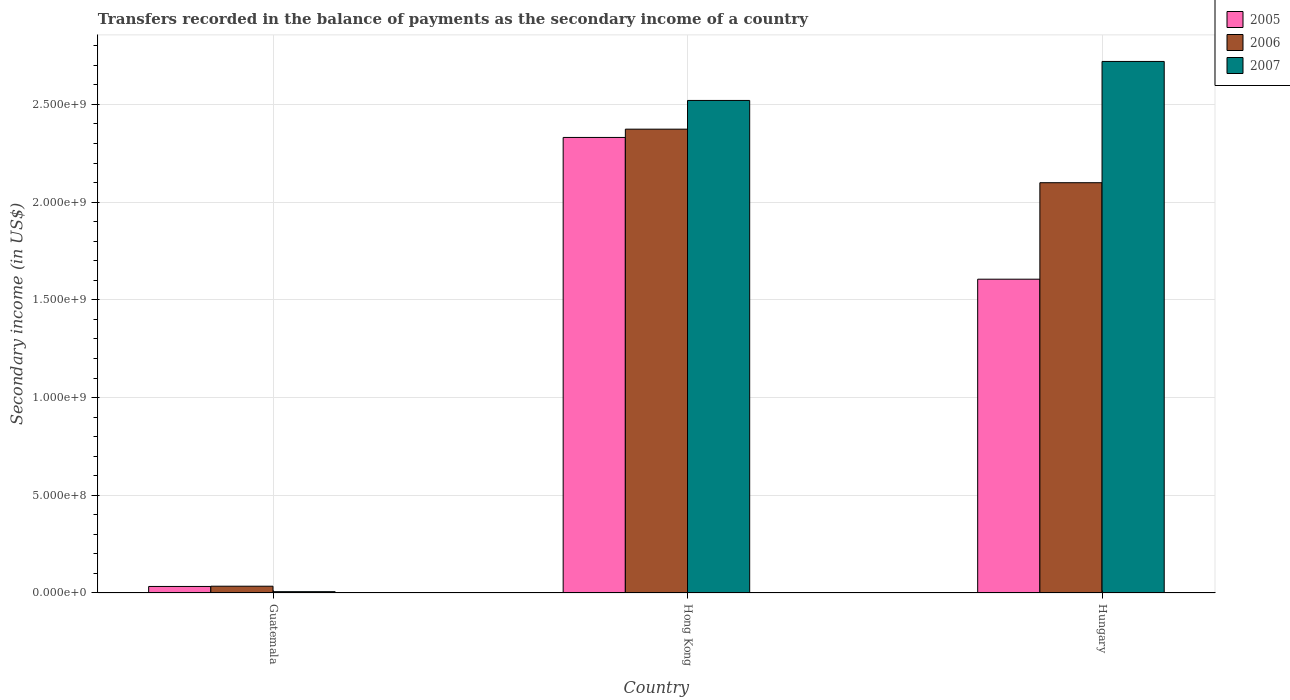How many different coloured bars are there?
Give a very brief answer. 3. How many groups of bars are there?
Make the answer very short. 3. Are the number of bars on each tick of the X-axis equal?
Keep it short and to the point. Yes. What is the label of the 3rd group of bars from the left?
Offer a terse response. Hungary. What is the secondary income of in 2007 in Guatemala?
Give a very brief answer. 6.70e+06. Across all countries, what is the maximum secondary income of in 2007?
Keep it short and to the point. 2.72e+09. Across all countries, what is the minimum secondary income of in 2007?
Make the answer very short. 6.70e+06. In which country was the secondary income of in 2006 maximum?
Ensure brevity in your answer.  Hong Kong. In which country was the secondary income of in 2007 minimum?
Offer a very short reply. Guatemala. What is the total secondary income of in 2006 in the graph?
Offer a terse response. 4.51e+09. What is the difference between the secondary income of in 2007 in Guatemala and that in Hungary?
Provide a short and direct response. -2.71e+09. What is the difference between the secondary income of in 2005 in Hungary and the secondary income of in 2006 in Hong Kong?
Offer a terse response. -7.68e+08. What is the average secondary income of in 2007 per country?
Offer a terse response. 1.75e+09. What is the difference between the secondary income of of/in 2007 and secondary income of of/in 2005 in Hungary?
Your answer should be compact. 1.11e+09. What is the ratio of the secondary income of in 2007 in Guatemala to that in Hungary?
Keep it short and to the point. 0. Is the secondary income of in 2007 in Guatemala less than that in Hungary?
Offer a very short reply. Yes. What is the difference between the highest and the second highest secondary income of in 2005?
Keep it short and to the point. -1.57e+09. What is the difference between the highest and the lowest secondary income of in 2005?
Your answer should be very brief. 2.30e+09. What does the 2nd bar from the right in Hong Kong represents?
Your answer should be compact. 2006. How many bars are there?
Offer a terse response. 9. Are all the bars in the graph horizontal?
Offer a terse response. No. How many countries are there in the graph?
Offer a terse response. 3. What is the difference between two consecutive major ticks on the Y-axis?
Ensure brevity in your answer.  5.00e+08. Are the values on the major ticks of Y-axis written in scientific E-notation?
Offer a terse response. Yes. Does the graph contain any zero values?
Your answer should be very brief. No. What is the title of the graph?
Offer a terse response. Transfers recorded in the balance of payments as the secondary income of a country. What is the label or title of the X-axis?
Ensure brevity in your answer.  Country. What is the label or title of the Y-axis?
Make the answer very short. Secondary income (in US$). What is the Secondary income (in US$) of 2005 in Guatemala?
Offer a terse response. 3.34e+07. What is the Secondary income (in US$) of 2006 in Guatemala?
Give a very brief answer. 3.47e+07. What is the Secondary income (in US$) of 2007 in Guatemala?
Ensure brevity in your answer.  6.70e+06. What is the Secondary income (in US$) of 2005 in Hong Kong?
Your response must be concise. 2.33e+09. What is the Secondary income (in US$) of 2006 in Hong Kong?
Your response must be concise. 2.37e+09. What is the Secondary income (in US$) of 2007 in Hong Kong?
Your response must be concise. 2.52e+09. What is the Secondary income (in US$) of 2005 in Hungary?
Ensure brevity in your answer.  1.61e+09. What is the Secondary income (in US$) in 2006 in Hungary?
Provide a succinct answer. 2.10e+09. What is the Secondary income (in US$) in 2007 in Hungary?
Give a very brief answer. 2.72e+09. Across all countries, what is the maximum Secondary income (in US$) in 2005?
Offer a terse response. 2.33e+09. Across all countries, what is the maximum Secondary income (in US$) in 2006?
Give a very brief answer. 2.37e+09. Across all countries, what is the maximum Secondary income (in US$) in 2007?
Your response must be concise. 2.72e+09. Across all countries, what is the minimum Secondary income (in US$) in 2005?
Provide a short and direct response. 3.34e+07. Across all countries, what is the minimum Secondary income (in US$) in 2006?
Your answer should be very brief. 3.47e+07. Across all countries, what is the minimum Secondary income (in US$) of 2007?
Ensure brevity in your answer.  6.70e+06. What is the total Secondary income (in US$) of 2005 in the graph?
Keep it short and to the point. 3.97e+09. What is the total Secondary income (in US$) in 2006 in the graph?
Offer a very short reply. 4.51e+09. What is the total Secondary income (in US$) of 2007 in the graph?
Provide a succinct answer. 5.25e+09. What is the difference between the Secondary income (in US$) in 2005 in Guatemala and that in Hong Kong?
Your answer should be very brief. -2.30e+09. What is the difference between the Secondary income (in US$) in 2006 in Guatemala and that in Hong Kong?
Keep it short and to the point. -2.34e+09. What is the difference between the Secondary income (in US$) in 2007 in Guatemala and that in Hong Kong?
Make the answer very short. -2.51e+09. What is the difference between the Secondary income (in US$) in 2005 in Guatemala and that in Hungary?
Ensure brevity in your answer.  -1.57e+09. What is the difference between the Secondary income (in US$) in 2006 in Guatemala and that in Hungary?
Keep it short and to the point. -2.06e+09. What is the difference between the Secondary income (in US$) of 2007 in Guatemala and that in Hungary?
Offer a very short reply. -2.71e+09. What is the difference between the Secondary income (in US$) of 2005 in Hong Kong and that in Hungary?
Ensure brevity in your answer.  7.25e+08. What is the difference between the Secondary income (in US$) in 2006 in Hong Kong and that in Hungary?
Offer a terse response. 2.74e+08. What is the difference between the Secondary income (in US$) in 2007 in Hong Kong and that in Hungary?
Provide a succinct answer. -1.99e+08. What is the difference between the Secondary income (in US$) of 2005 in Guatemala and the Secondary income (in US$) of 2006 in Hong Kong?
Your response must be concise. -2.34e+09. What is the difference between the Secondary income (in US$) of 2005 in Guatemala and the Secondary income (in US$) of 2007 in Hong Kong?
Your response must be concise. -2.49e+09. What is the difference between the Secondary income (in US$) of 2006 in Guatemala and the Secondary income (in US$) of 2007 in Hong Kong?
Your response must be concise. -2.49e+09. What is the difference between the Secondary income (in US$) of 2005 in Guatemala and the Secondary income (in US$) of 2006 in Hungary?
Give a very brief answer. -2.07e+09. What is the difference between the Secondary income (in US$) in 2005 in Guatemala and the Secondary income (in US$) in 2007 in Hungary?
Offer a very short reply. -2.69e+09. What is the difference between the Secondary income (in US$) in 2006 in Guatemala and the Secondary income (in US$) in 2007 in Hungary?
Offer a very short reply. -2.69e+09. What is the difference between the Secondary income (in US$) in 2005 in Hong Kong and the Secondary income (in US$) in 2006 in Hungary?
Your answer should be compact. 2.32e+08. What is the difference between the Secondary income (in US$) of 2005 in Hong Kong and the Secondary income (in US$) of 2007 in Hungary?
Make the answer very short. -3.89e+08. What is the difference between the Secondary income (in US$) in 2006 in Hong Kong and the Secondary income (in US$) in 2007 in Hungary?
Give a very brief answer. -3.47e+08. What is the average Secondary income (in US$) in 2005 per country?
Offer a very short reply. 1.32e+09. What is the average Secondary income (in US$) in 2006 per country?
Your response must be concise. 1.50e+09. What is the average Secondary income (in US$) of 2007 per country?
Provide a succinct answer. 1.75e+09. What is the difference between the Secondary income (in US$) of 2005 and Secondary income (in US$) of 2006 in Guatemala?
Provide a short and direct response. -1.30e+06. What is the difference between the Secondary income (in US$) of 2005 and Secondary income (in US$) of 2007 in Guatemala?
Keep it short and to the point. 2.67e+07. What is the difference between the Secondary income (in US$) in 2006 and Secondary income (in US$) in 2007 in Guatemala?
Offer a very short reply. 2.80e+07. What is the difference between the Secondary income (in US$) of 2005 and Secondary income (in US$) of 2006 in Hong Kong?
Offer a terse response. -4.24e+07. What is the difference between the Secondary income (in US$) of 2005 and Secondary income (in US$) of 2007 in Hong Kong?
Your answer should be compact. -1.89e+08. What is the difference between the Secondary income (in US$) of 2006 and Secondary income (in US$) of 2007 in Hong Kong?
Your answer should be very brief. -1.47e+08. What is the difference between the Secondary income (in US$) of 2005 and Secondary income (in US$) of 2006 in Hungary?
Give a very brief answer. -4.94e+08. What is the difference between the Secondary income (in US$) of 2005 and Secondary income (in US$) of 2007 in Hungary?
Ensure brevity in your answer.  -1.11e+09. What is the difference between the Secondary income (in US$) of 2006 and Secondary income (in US$) of 2007 in Hungary?
Ensure brevity in your answer.  -6.20e+08. What is the ratio of the Secondary income (in US$) of 2005 in Guatemala to that in Hong Kong?
Keep it short and to the point. 0.01. What is the ratio of the Secondary income (in US$) of 2006 in Guatemala to that in Hong Kong?
Offer a very short reply. 0.01. What is the ratio of the Secondary income (in US$) in 2007 in Guatemala to that in Hong Kong?
Keep it short and to the point. 0. What is the ratio of the Secondary income (in US$) of 2005 in Guatemala to that in Hungary?
Provide a succinct answer. 0.02. What is the ratio of the Secondary income (in US$) of 2006 in Guatemala to that in Hungary?
Offer a very short reply. 0.02. What is the ratio of the Secondary income (in US$) of 2007 in Guatemala to that in Hungary?
Offer a very short reply. 0. What is the ratio of the Secondary income (in US$) of 2005 in Hong Kong to that in Hungary?
Make the answer very short. 1.45. What is the ratio of the Secondary income (in US$) in 2006 in Hong Kong to that in Hungary?
Keep it short and to the point. 1.13. What is the ratio of the Secondary income (in US$) in 2007 in Hong Kong to that in Hungary?
Ensure brevity in your answer.  0.93. What is the difference between the highest and the second highest Secondary income (in US$) of 2005?
Give a very brief answer. 7.25e+08. What is the difference between the highest and the second highest Secondary income (in US$) in 2006?
Give a very brief answer. 2.74e+08. What is the difference between the highest and the second highest Secondary income (in US$) of 2007?
Provide a succinct answer. 1.99e+08. What is the difference between the highest and the lowest Secondary income (in US$) of 2005?
Offer a very short reply. 2.30e+09. What is the difference between the highest and the lowest Secondary income (in US$) of 2006?
Offer a terse response. 2.34e+09. What is the difference between the highest and the lowest Secondary income (in US$) of 2007?
Offer a very short reply. 2.71e+09. 